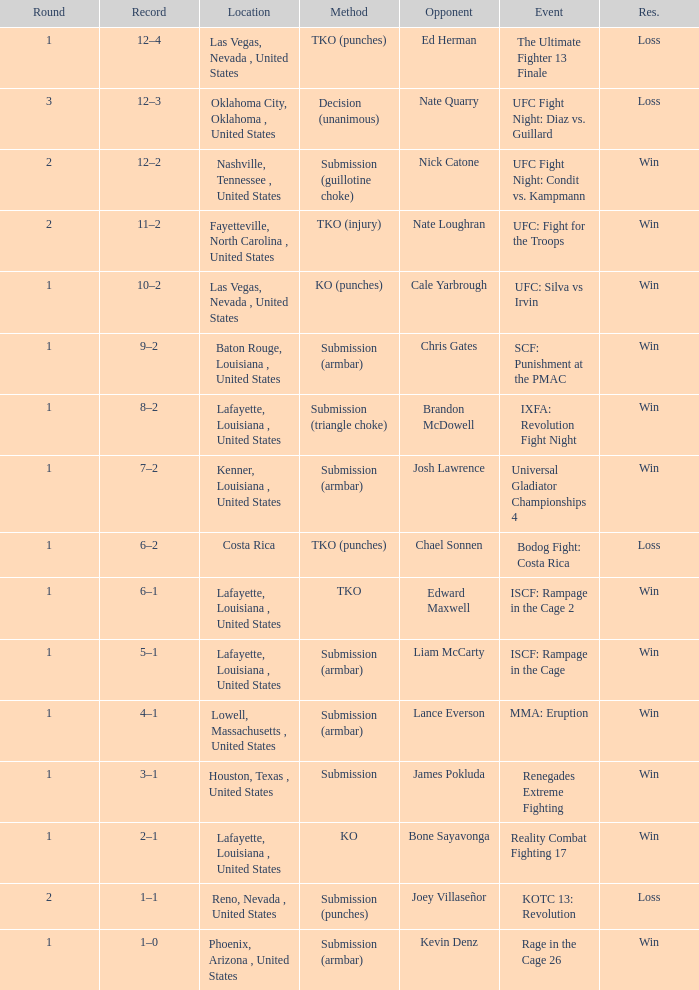What's was the location for fight against Liam Mccarty? Lafayette, Louisiana , United States. 